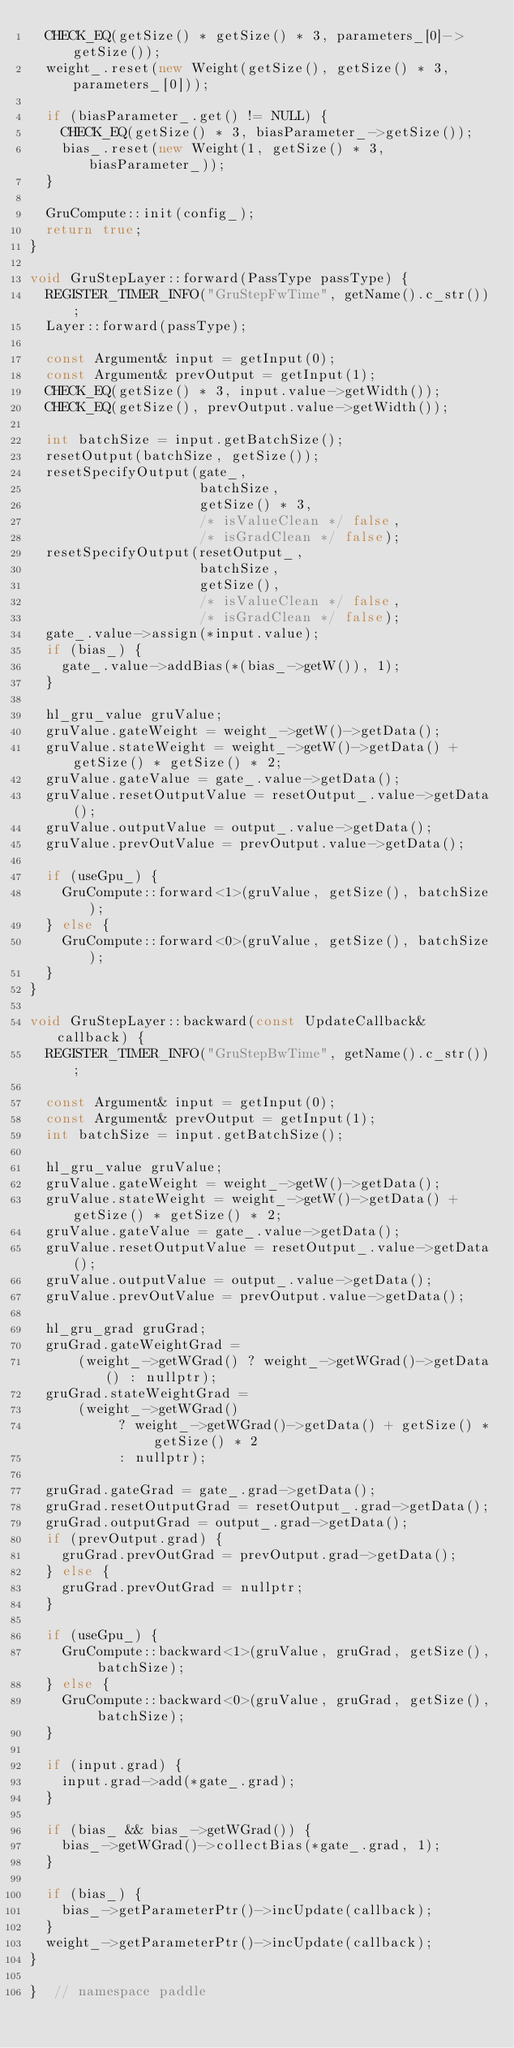<code> <loc_0><loc_0><loc_500><loc_500><_C++_>  CHECK_EQ(getSize() * getSize() * 3, parameters_[0]->getSize());
  weight_.reset(new Weight(getSize(), getSize() * 3, parameters_[0]));

  if (biasParameter_.get() != NULL) {
    CHECK_EQ(getSize() * 3, biasParameter_->getSize());
    bias_.reset(new Weight(1, getSize() * 3, biasParameter_));
  }

  GruCompute::init(config_);
  return true;
}

void GruStepLayer::forward(PassType passType) {
  REGISTER_TIMER_INFO("GruStepFwTime", getName().c_str());
  Layer::forward(passType);

  const Argument& input = getInput(0);
  const Argument& prevOutput = getInput(1);
  CHECK_EQ(getSize() * 3, input.value->getWidth());
  CHECK_EQ(getSize(), prevOutput.value->getWidth());

  int batchSize = input.getBatchSize();
  resetOutput(batchSize, getSize());
  resetSpecifyOutput(gate_,
                     batchSize,
                     getSize() * 3,
                     /* isValueClean */ false,
                     /* isGradClean */ false);
  resetSpecifyOutput(resetOutput_,
                     batchSize,
                     getSize(),
                     /* isValueClean */ false,
                     /* isGradClean */ false);
  gate_.value->assign(*input.value);
  if (bias_) {
    gate_.value->addBias(*(bias_->getW()), 1);
  }

  hl_gru_value gruValue;
  gruValue.gateWeight = weight_->getW()->getData();
  gruValue.stateWeight = weight_->getW()->getData() + getSize() * getSize() * 2;
  gruValue.gateValue = gate_.value->getData();
  gruValue.resetOutputValue = resetOutput_.value->getData();
  gruValue.outputValue = output_.value->getData();
  gruValue.prevOutValue = prevOutput.value->getData();

  if (useGpu_) {
    GruCompute::forward<1>(gruValue, getSize(), batchSize);
  } else {
    GruCompute::forward<0>(gruValue, getSize(), batchSize);
  }
}

void GruStepLayer::backward(const UpdateCallback& callback) {
  REGISTER_TIMER_INFO("GruStepBwTime", getName().c_str());

  const Argument& input = getInput(0);
  const Argument& prevOutput = getInput(1);
  int batchSize = input.getBatchSize();

  hl_gru_value gruValue;
  gruValue.gateWeight = weight_->getW()->getData();
  gruValue.stateWeight = weight_->getW()->getData() + getSize() * getSize() * 2;
  gruValue.gateValue = gate_.value->getData();
  gruValue.resetOutputValue = resetOutput_.value->getData();
  gruValue.outputValue = output_.value->getData();
  gruValue.prevOutValue = prevOutput.value->getData();

  hl_gru_grad gruGrad;
  gruGrad.gateWeightGrad =
      (weight_->getWGrad() ? weight_->getWGrad()->getData() : nullptr);
  gruGrad.stateWeightGrad =
      (weight_->getWGrad()
           ? weight_->getWGrad()->getData() + getSize() * getSize() * 2
           : nullptr);

  gruGrad.gateGrad = gate_.grad->getData();
  gruGrad.resetOutputGrad = resetOutput_.grad->getData();
  gruGrad.outputGrad = output_.grad->getData();
  if (prevOutput.grad) {
    gruGrad.prevOutGrad = prevOutput.grad->getData();
  } else {
    gruGrad.prevOutGrad = nullptr;
  }

  if (useGpu_) {
    GruCompute::backward<1>(gruValue, gruGrad, getSize(), batchSize);
  } else {
    GruCompute::backward<0>(gruValue, gruGrad, getSize(), batchSize);
  }

  if (input.grad) {
    input.grad->add(*gate_.grad);
  }

  if (bias_ && bias_->getWGrad()) {
    bias_->getWGrad()->collectBias(*gate_.grad, 1);
  }

  if (bias_) {
    bias_->getParameterPtr()->incUpdate(callback);
  }
  weight_->getParameterPtr()->incUpdate(callback);
}

}  // namespace paddle
</code> 